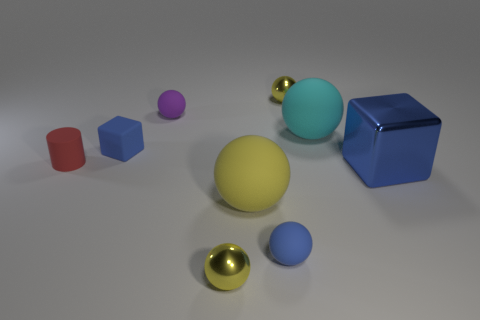There is a tiny yellow thing that is to the left of the tiny metal sphere that is behind the small blue object that is in front of the red rubber object; what is its shape? The tiny yellow object in question is indeed a sphere. It's positioned thoughtfully to the left of a small, shining metal sphere, which in turn is delicately placed behind a quaint blue cube and in front of a vibrant, red cuboid, all of which contribute to a harmonious composition of colorful geometric shapes. 